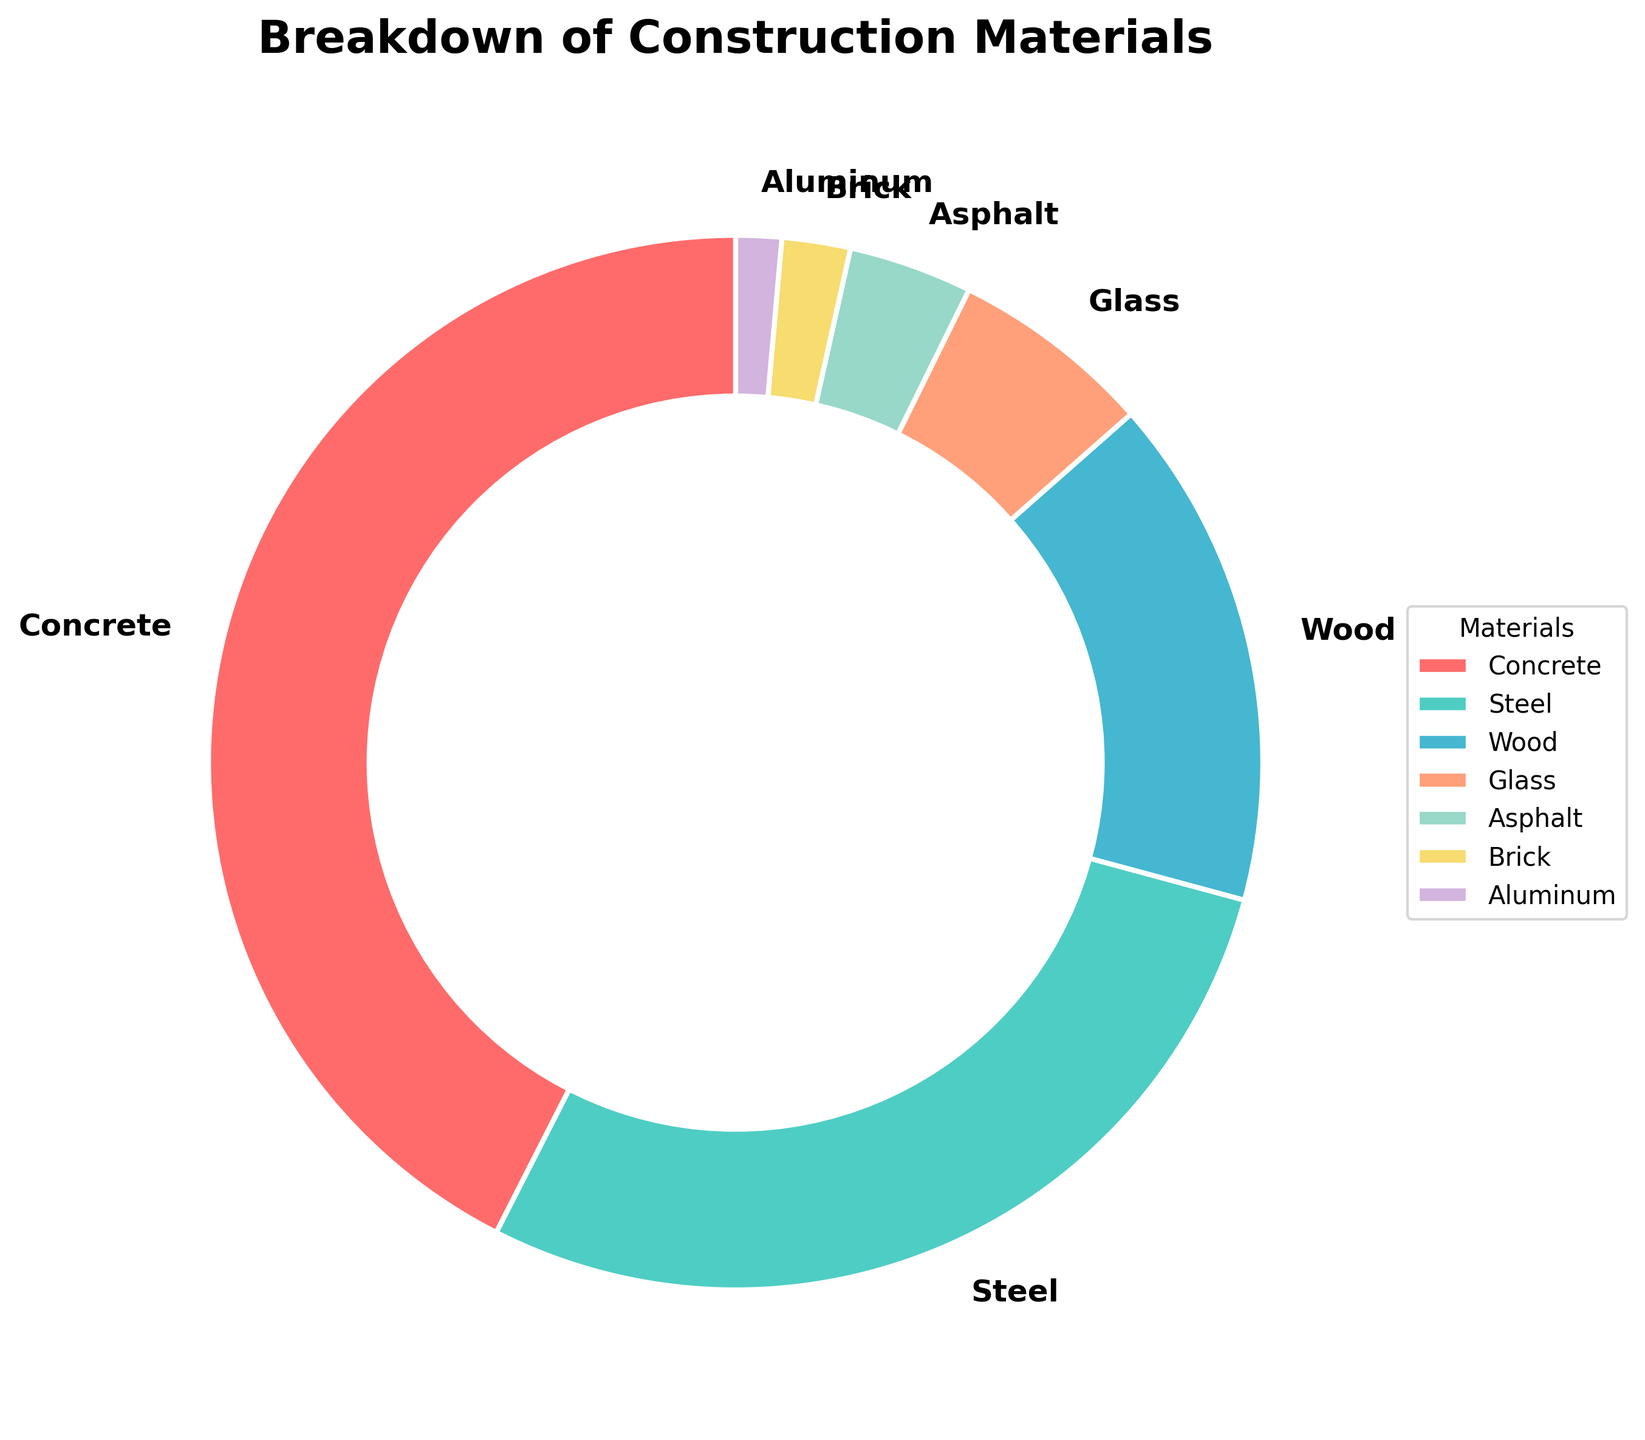What percentage of the materials used is concrete? Look at the slice labeled "Concrete" in the pie chart to find the percentage. According to the figure, the concrete slice is labeled with 42.5%.
Answer: 42.5% Which material has the second-largest percentage? Find the slice with the second largest section after Concrete. The slice labeled "Steel" has the second-largest percentage at 28.3%.
Answer: Steel What is the combined percentage for Wood and Glass? Look at the slices labeled "Wood" and "Glass" and add their percentages. Wood has 15.7% and Glass has 6.2%, so the combined percentage is 15.7% + 6.2% = 21.9%.
Answer: 21.9% Is the percentage of Steel greater than the combined percentage of Asphalt and Brick? Check the percentage for Steel (28.3%) and calculate the combined percentage for Asphalt and Brick (3.8% + 2.1% = 5.9%), then compare. 28.3% is greater than 5.9%.
Answer: Yes What material is represented by the smallest slice, and what is its percentage? Identify the smallest slice in the pie chart. The smallest slice represents Aluminum with a percentage of 1.4%.
Answer: Aluminum, 1.4% How much greater is the percentage of Concrete compared to the percentage of Wood? Subtract the percentage of Wood (15.7%) from the percentage of Concrete (42.5%). 42.5% - 15.7% = 26.8%.
Answer: 26.8% Which materials have a percentage less than 5%? Identify the slices labeled with percentages less than 5%. The materials are Asphalt (3.8%), Brick (2.1%), and Aluminum (1.4%).
Answer: Asphalt, Brick, Aluminum Which slices are colored red and blue, respectively? Find the slice colored red and the slice colored blue. In the pie chart, Concrete is colored red, and Steel is colored blue.
Answer: Concrete (red), Steel (blue) How does the percentage of Wood compare to that of Glass in terms of visual size? Compare the size of the slices labeled Wood and Glass. The Wood slice is larger with 15.7%, while the Glass slice is smaller with 6.2%.
Answer: Wood is larger If you combined the percentages of Steel, Asphalt, and Brick, would the total be more or less than the percentage of Concrete? Add the percentages of Steel (28.3%), Asphalt (3.8%), and Brick (2.1%) and compare the total to the percentage of Concrete (42.5%). The combined percentage is 28.3% + 3.8% + 2.1% = 34.2%, which is less than 42.5%.
Answer: Less 